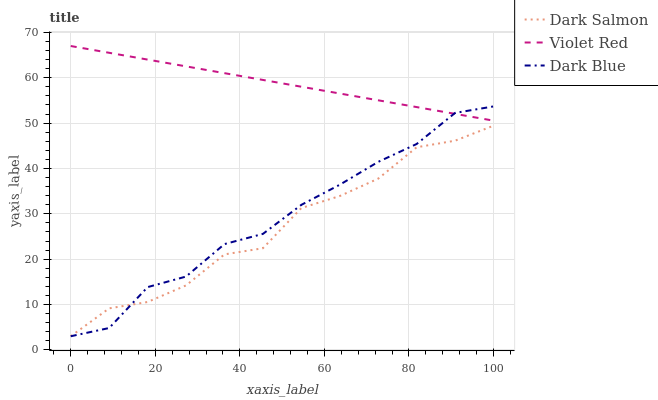Does Dark Salmon have the minimum area under the curve?
Answer yes or no. Yes. Does Violet Red have the maximum area under the curve?
Answer yes or no. Yes. Does Violet Red have the minimum area under the curve?
Answer yes or no. No. Does Dark Salmon have the maximum area under the curve?
Answer yes or no. No. Is Violet Red the smoothest?
Answer yes or no. Yes. Is Dark Salmon the roughest?
Answer yes or no. Yes. Is Dark Salmon the smoothest?
Answer yes or no. No. Is Violet Red the roughest?
Answer yes or no. No. Does Violet Red have the lowest value?
Answer yes or no. No. Does Violet Red have the highest value?
Answer yes or no. Yes. Does Dark Salmon have the highest value?
Answer yes or no. No. Is Dark Salmon less than Violet Red?
Answer yes or no. Yes. Is Violet Red greater than Dark Salmon?
Answer yes or no. Yes. Does Dark Blue intersect Violet Red?
Answer yes or no. Yes. Is Dark Blue less than Violet Red?
Answer yes or no. No. Is Dark Blue greater than Violet Red?
Answer yes or no. No. Does Dark Salmon intersect Violet Red?
Answer yes or no. No. 